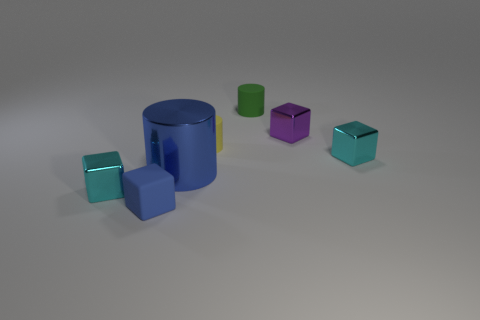What might be the purpose of arranging these objects like this? This arrangement of objects might be for visual or aesthetic purposes, possibly for a graphic design or 3D modeling demonstration. The varying colors and shapes could serve to show off rendering capabilities or for an educational display about geometry and light in computer-generated imagery. 